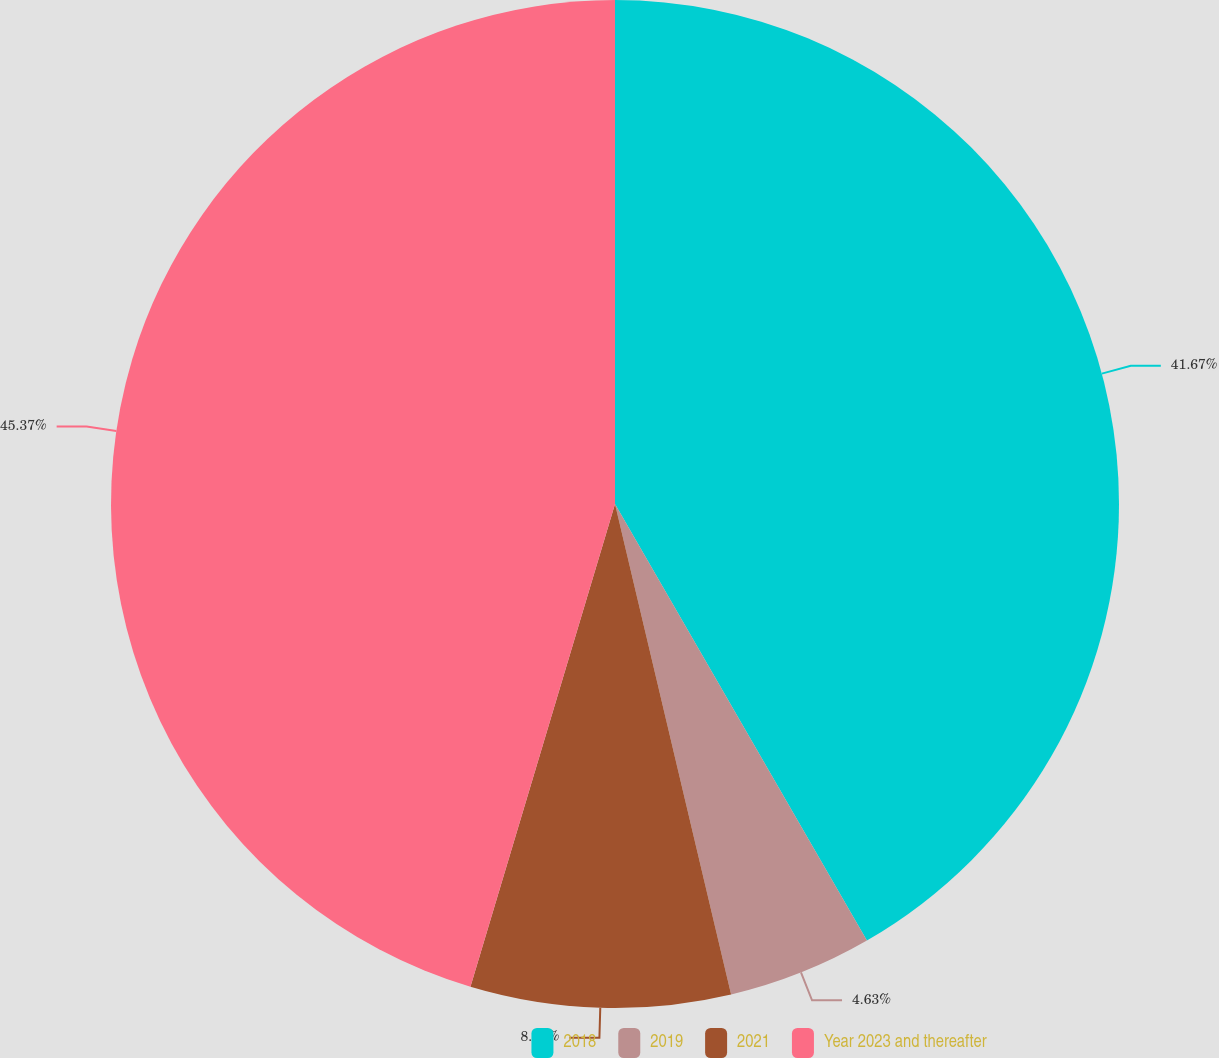Convert chart to OTSL. <chart><loc_0><loc_0><loc_500><loc_500><pie_chart><fcel>2018<fcel>2019<fcel>2021<fcel>Year 2023 and thereafter<nl><fcel>41.67%<fcel>4.63%<fcel>8.33%<fcel>45.37%<nl></chart> 